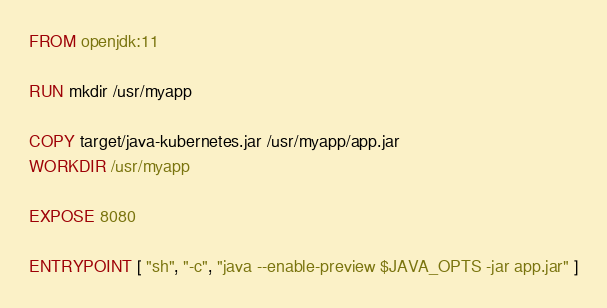<code> <loc_0><loc_0><loc_500><loc_500><_Dockerfile_>FROM openjdk:11

RUN mkdir /usr/myapp

COPY target/java-kubernetes.jar /usr/myapp/app.jar
WORKDIR /usr/myapp

EXPOSE 8080

ENTRYPOINT [ "sh", "-c", "java --enable-preview $JAVA_OPTS -jar app.jar" ]
</code> 